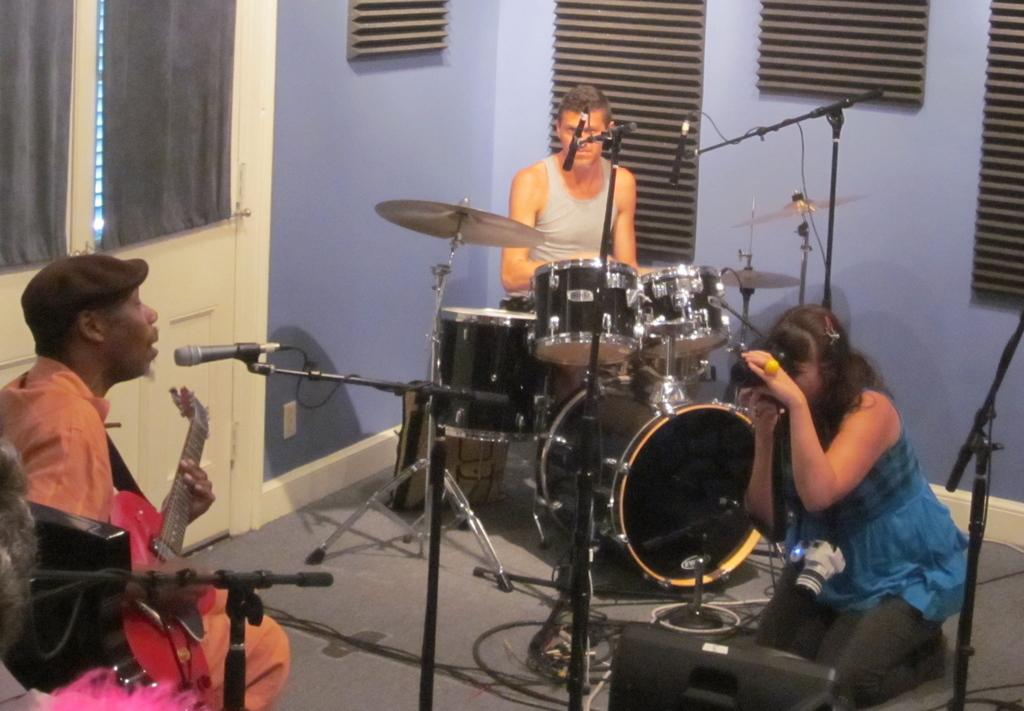How many people are in the image? There are three people in the image. What are the people doing in the image? The presence of musical instruments and microphones suggests that the people are performing or rehearsing. What equipment is visible in the image that might be used for recording or amplifying sound? Cameras and microphones are visible in the image. What type of infrastructure is present in the image? There are walls visible in the image, which suggests that the image is taken in an indoor space. What other objects are present in the image that are not specified in the facts? There are some unspecified objects in the image. What type of stove is visible in the image? There is no stove present in the image. How many houses are visible in the image? There are no houses visible in the image. 